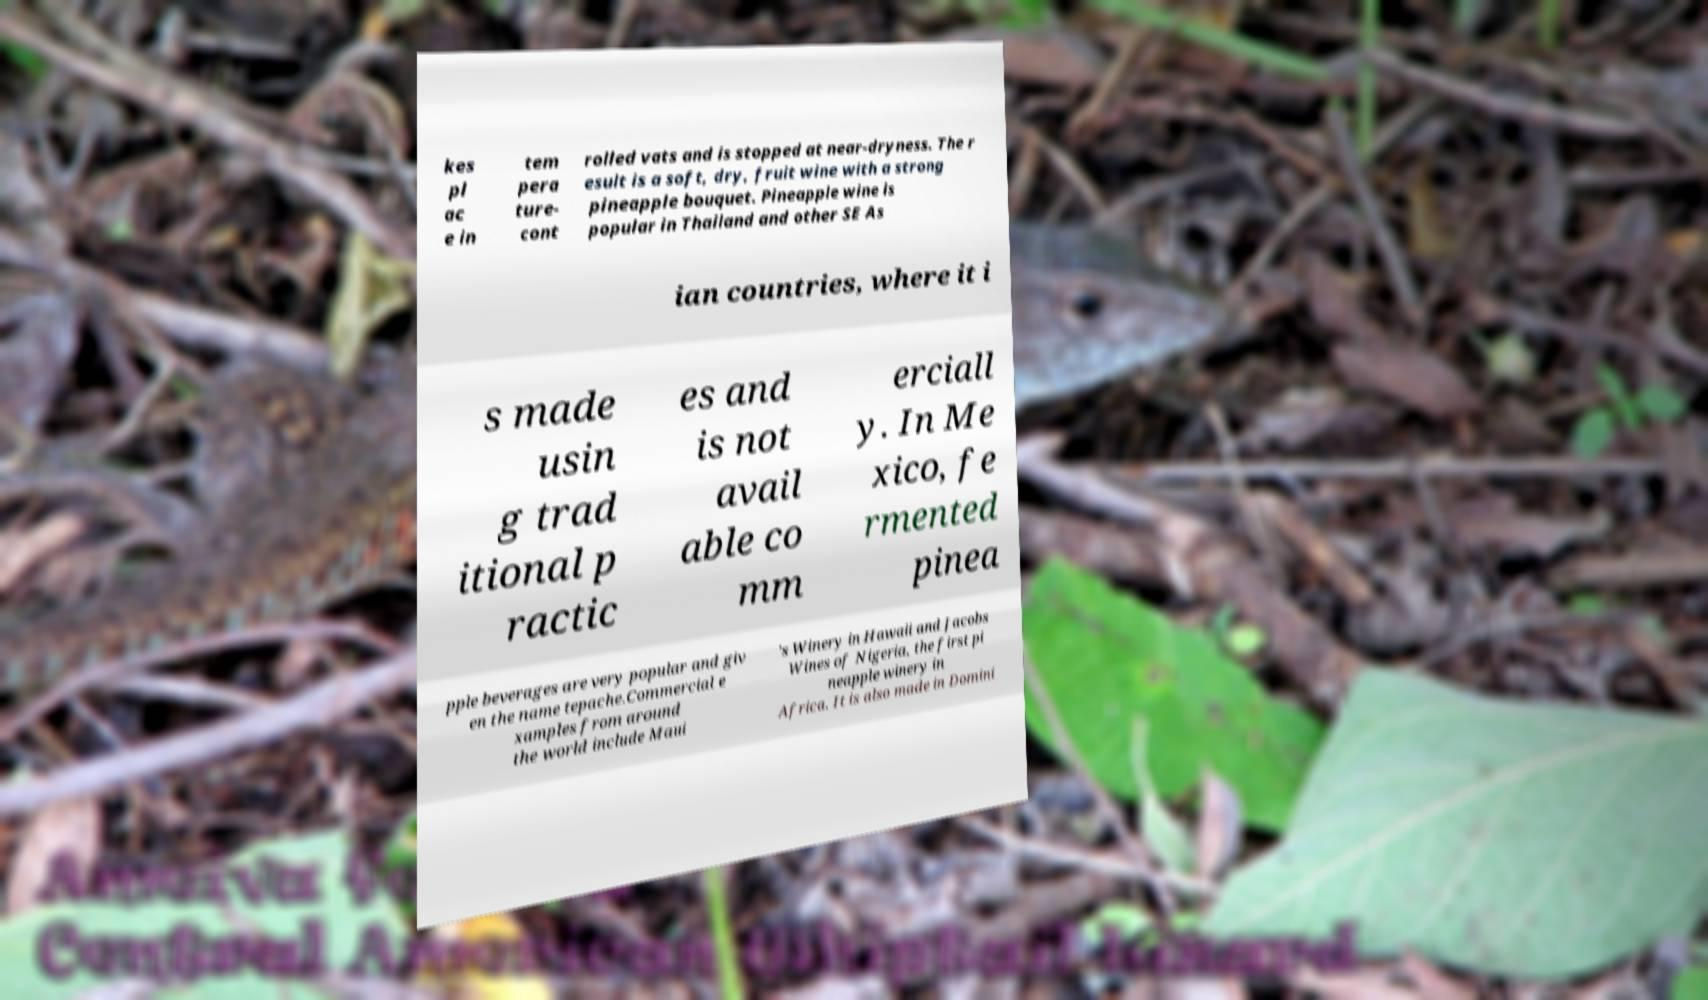There's text embedded in this image that I need extracted. Can you transcribe it verbatim? kes pl ac e in tem pera ture- cont rolled vats and is stopped at near-dryness. The r esult is a soft, dry, fruit wine with a strong pineapple bouquet. Pineapple wine is popular in Thailand and other SE As ian countries, where it i s made usin g trad itional p ractic es and is not avail able co mm erciall y. In Me xico, fe rmented pinea pple beverages are very popular and giv en the name tepache.Commercial e xamples from around the world include Maui 's Winery in Hawaii and Jacobs Wines of Nigeria, the first pi neapple winery in Africa. It is also made in Domini 